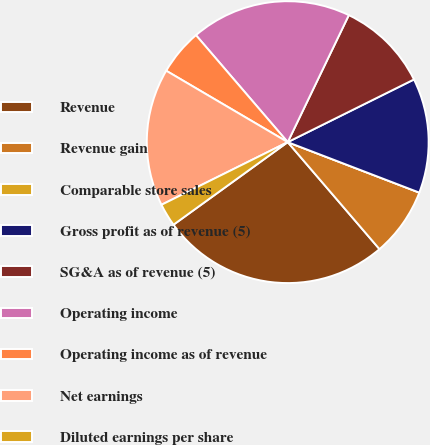Convert chart. <chart><loc_0><loc_0><loc_500><loc_500><pie_chart><fcel>Revenue<fcel>Revenue gain<fcel>Comparable store sales<fcel>Gross profit as of revenue (5)<fcel>SG&A as of revenue (5)<fcel>Operating income<fcel>Operating income as of revenue<fcel>Net earnings<fcel>Diluted earnings per share<nl><fcel>26.32%<fcel>7.89%<fcel>0.0%<fcel>13.16%<fcel>10.53%<fcel>18.42%<fcel>5.26%<fcel>15.79%<fcel>2.63%<nl></chart> 